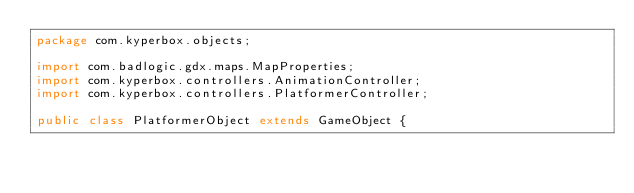<code> <loc_0><loc_0><loc_500><loc_500><_Java_>package com.kyperbox.objects;

import com.badlogic.gdx.maps.MapProperties;
import com.kyperbox.controllers.AnimationController;
import com.kyperbox.controllers.PlatformerController;

public class PlatformerObject extends GameObject {
</code> 